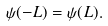<formula> <loc_0><loc_0><loc_500><loc_500>\psi ( - L ) = \psi ( L ) .</formula> 